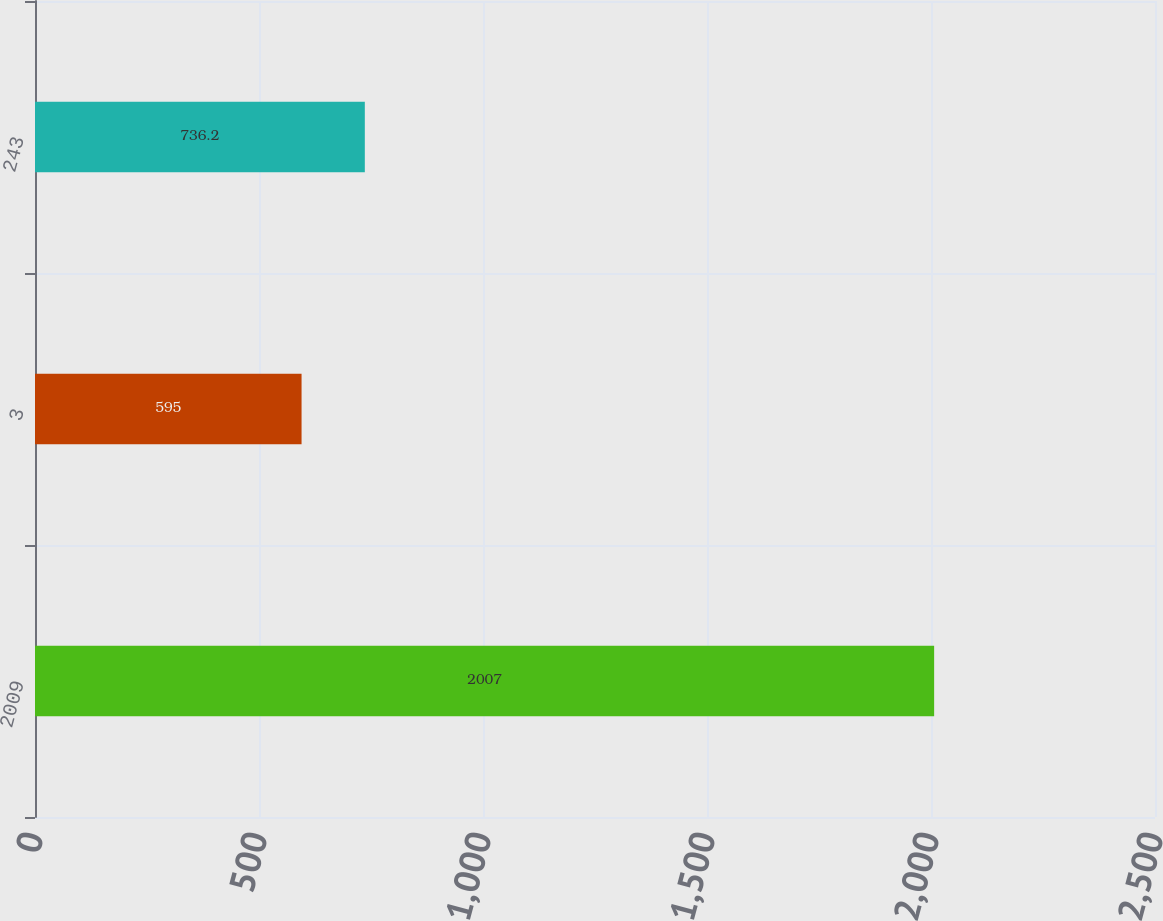Convert chart to OTSL. <chart><loc_0><loc_0><loc_500><loc_500><bar_chart><fcel>2009<fcel>3<fcel>243<nl><fcel>2007<fcel>595<fcel>736.2<nl></chart> 